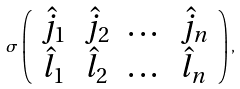<formula> <loc_0><loc_0><loc_500><loc_500>\sigma \left ( \begin{array} { c c c c } \hat { j } _ { 1 } & \hat { j } _ { 2 } & \dots & \hat { j } _ { n } \\ \hat { l } _ { 1 } & \hat { l } _ { 2 } & \dots & \hat { l } _ { n } \end{array} \right ) ,</formula> 